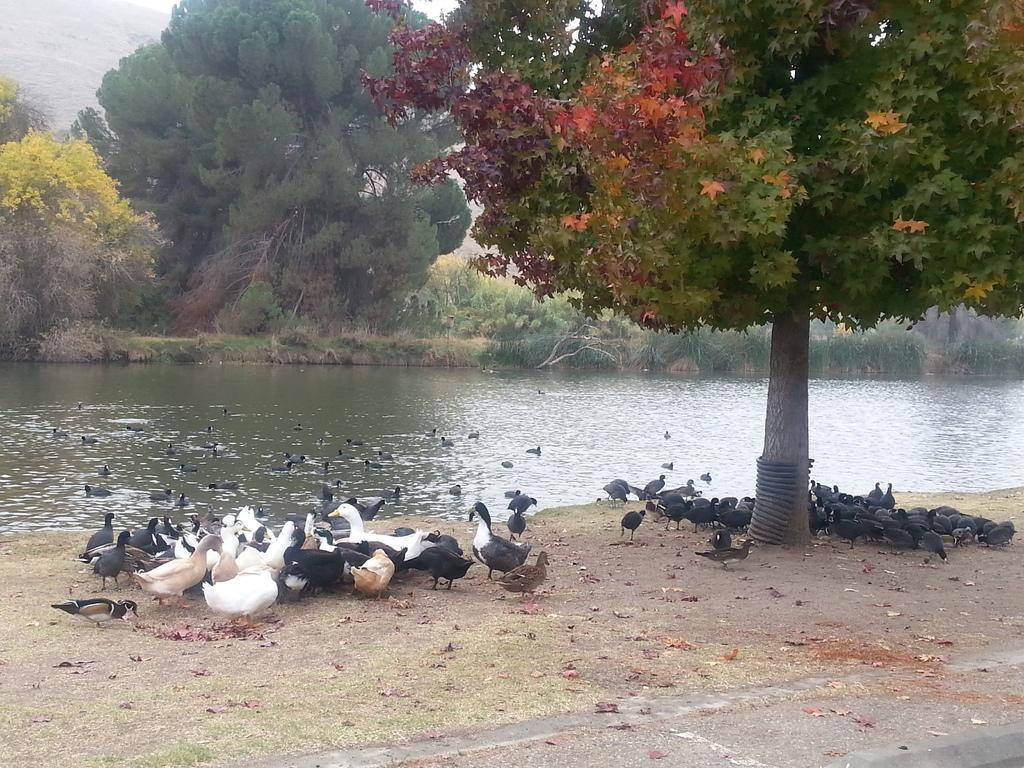Please provide a concise description of this image. In this image I can see few trees, water and few birds. Birds are in black, brown and white color. 